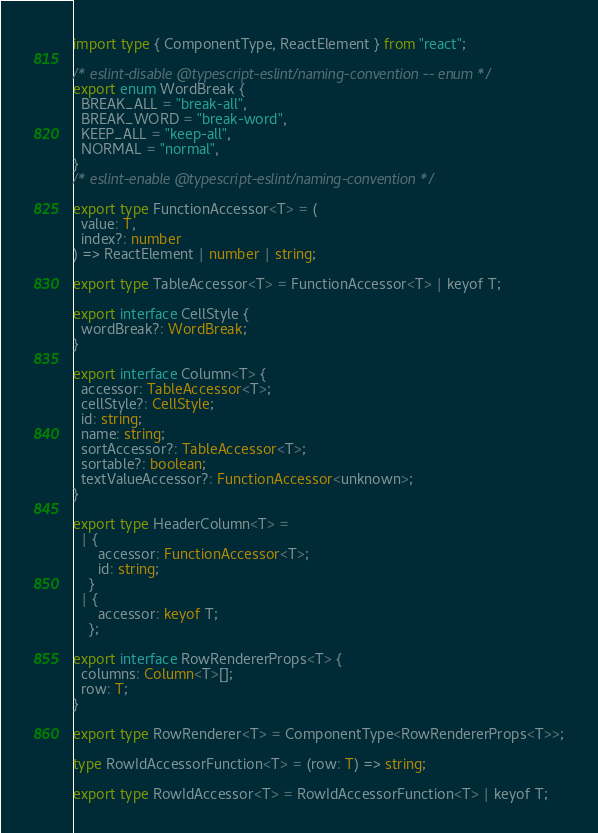<code> <loc_0><loc_0><loc_500><loc_500><_TypeScript_>import type { ComponentType, ReactElement } from "react";

/* eslint-disable @typescript-eslint/naming-convention -- enum */
export enum WordBreak {
  BREAK_ALL = "break-all",
  BREAK_WORD = "break-word",
  KEEP_ALL = "keep-all",
  NORMAL = "normal",
}
/* eslint-enable @typescript-eslint/naming-convention */

export type FunctionAccessor<T> = (
  value: T,
  index?: number
) => ReactElement | number | string;

export type TableAccessor<T> = FunctionAccessor<T> | keyof T;

export interface CellStyle {
  wordBreak?: WordBreak;
}

export interface Column<T> {
  accessor: TableAccessor<T>;
  cellStyle?: CellStyle;
  id: string;
  name: string;
  sortAccessor?: TableAccessor<T>;
  sortable?: boolean;
  textValueAccessor?: FunctionAccessor<unknown>;
}

export type HeaderColumn<T> =
  | {
      accessor: FunctionAccessor<T>;
      id: string;
    }
  | {
      accessor: keyof T;
    };

export interface RowRendererProps<T> {
  columns: Column<T>[];
  row: T;
}

export type RowRenderer<T> = ComponentType<RowRendererProps<T>>;

type RowIdAccessorFunction<T> = (row: T) => string;

export type RowIdAccessor<T> = RowIdAccessorFunction<T> | keyof T;
</code> 